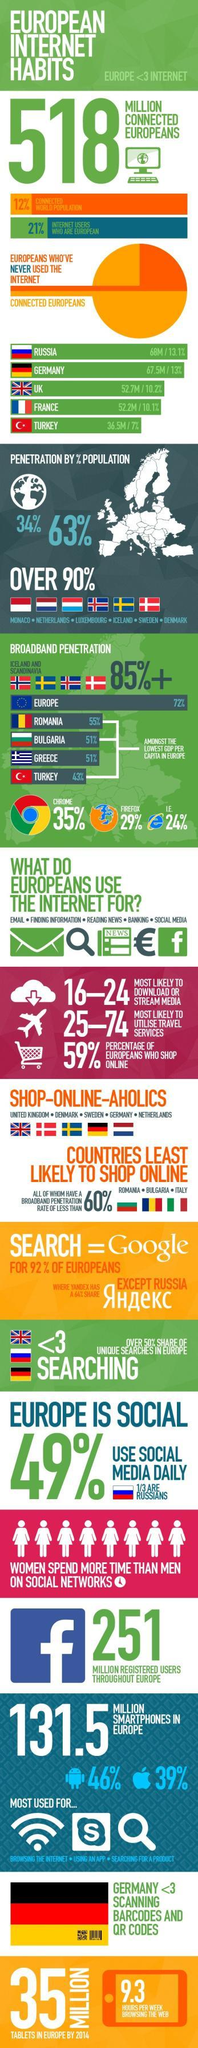Which country has the third highest internet users?
Answer the question with a short phrase. UK How many Scandinavian countries are compared for broadband penetration? 4 What percentage of users use Android smartphones in Europe? 46% What percentage of internet users are not Europeans? 79% What is the internet penetration percentage by population globally, 34%, 63%, or 90%?? 34% Which web browser is the most preferred by the Europeans, Firefox, IE, or Google Chrome? Google Chrome What percentage of users use Apple smartphones in Europe? 39% How many countries use internet to shop online the most? 5 